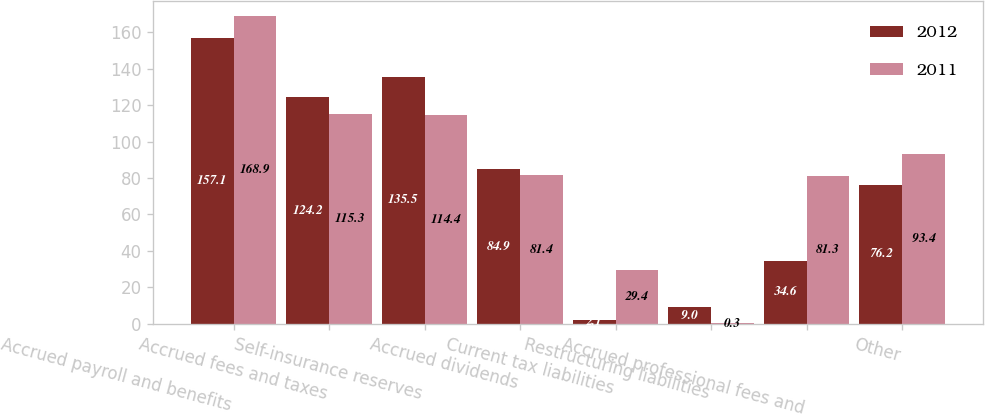<chart> <loc_0><loc_0><loc_500><loc_500><stacked_bar_chart><ecel><fcel>Accrued payroll and benefits<fcel>Accrued fees and taxes<fcel>Self-insurance reserves<fcel>Accrued dividends<fcel>Current tax liabilities<fcel>Restructuring liabilities<fcel>Accrued professional fees and<fcel>Other<nl><fcel>2012<fcel>157.1<fcel>124.2<fcel>135.5<fcel>84.9<fcel>2.1<fcel>9<fcel>34.6<fcel>76.2<nl><fcel>2011<fcel>168.9<fcel>115.3<fcel>114.4<fcel>81.4<fcel>29.4<fcel>0.3<fcel>81.3<fcel>93.4<nl></chart> 